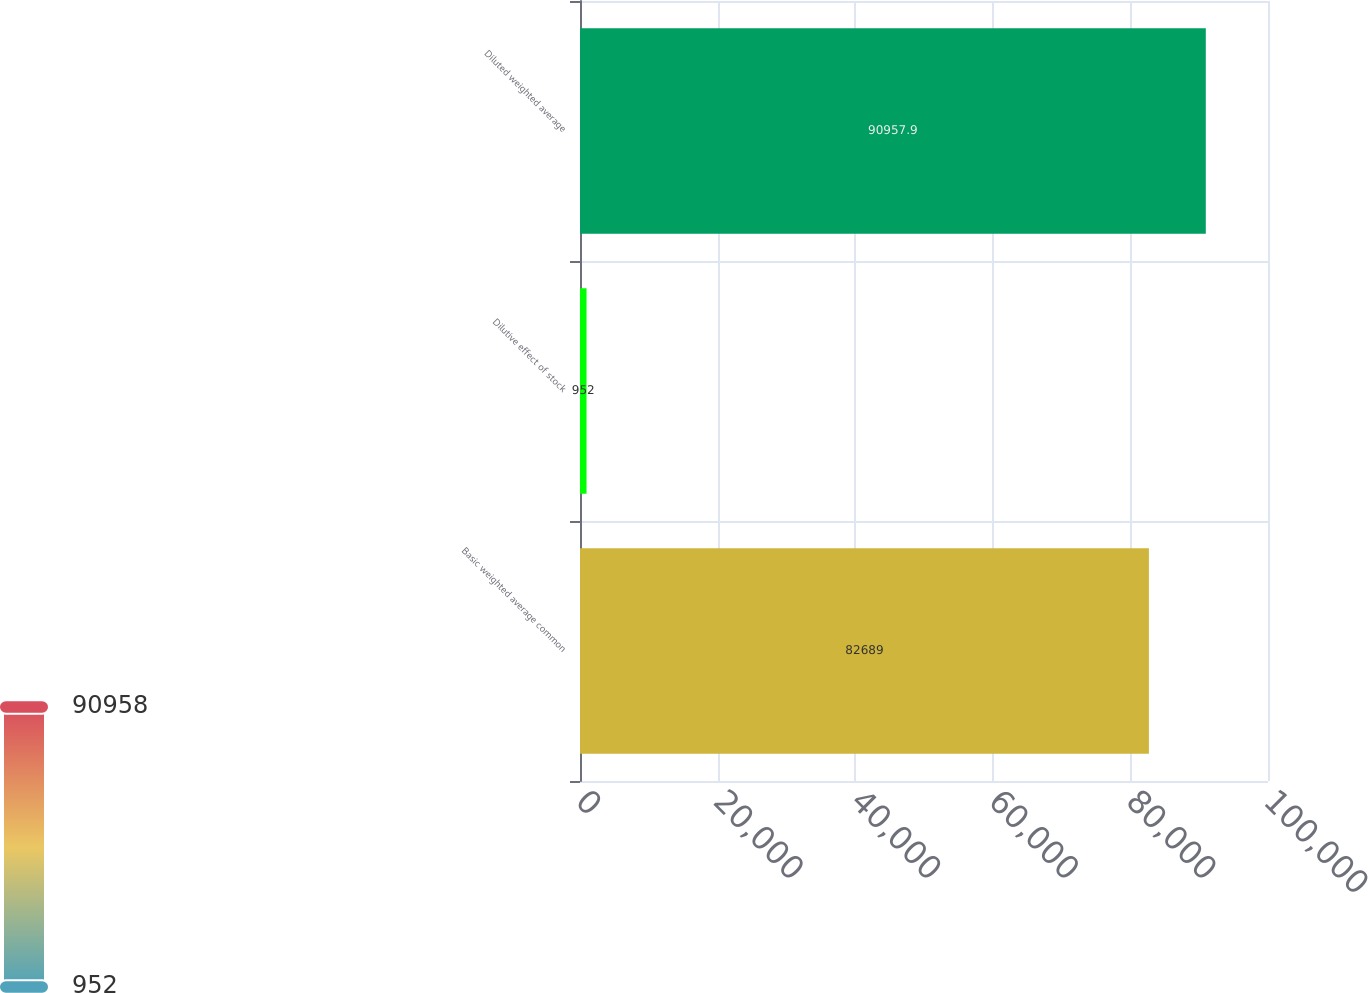<chart> <loc_0><loc_0><loc_500><loc_500><bar_chart><fcel>Basic weighted average common<fcel>Dilutive effect of stock<fcel>Diluted weighted average<nl><fcel>82689<fcel>952<fcel>90957.9<nl></chart> 